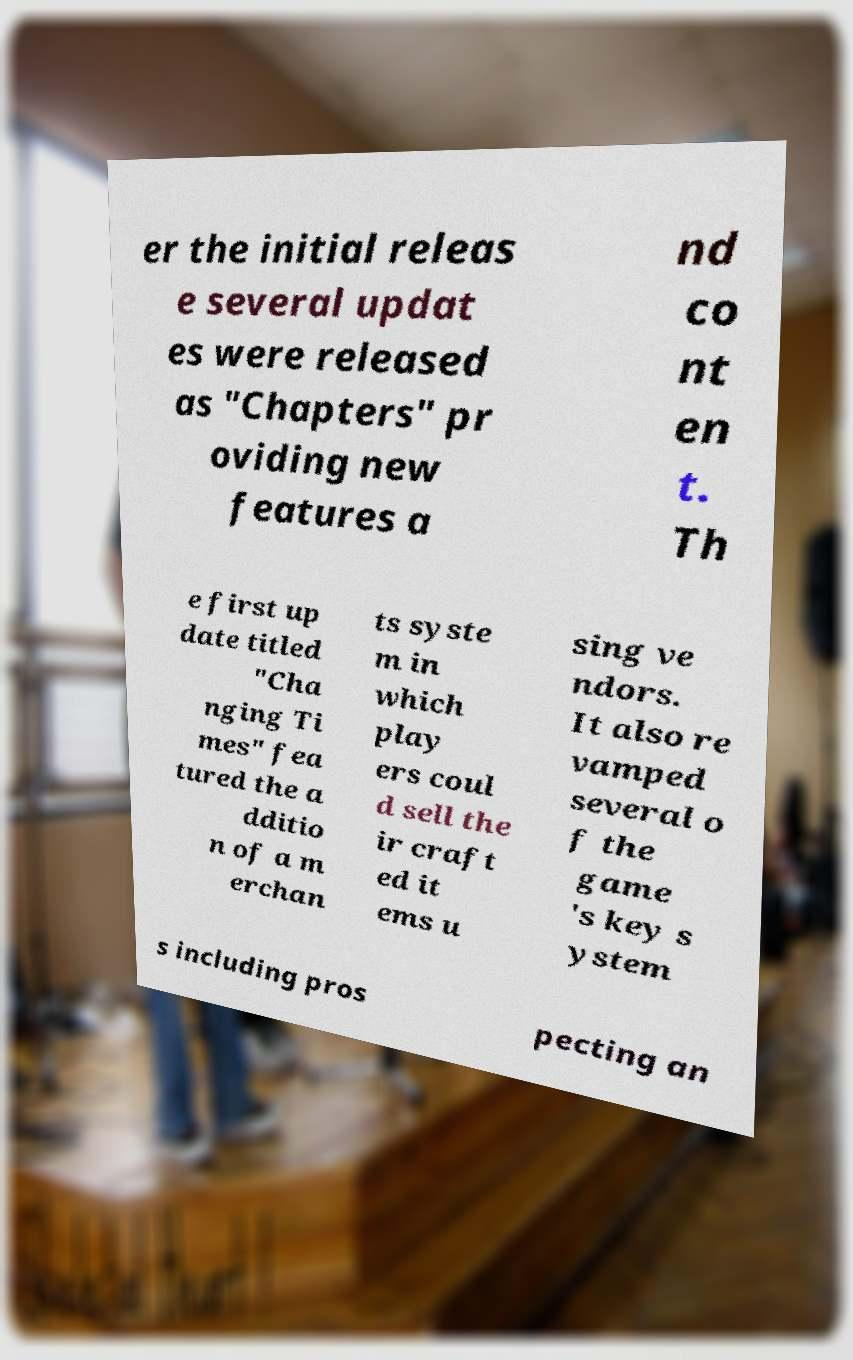Please read and relay the text visible in this image. What does it say? er the initial releas e several updat es were released as "Chapters" pr oviding new features a nd co nt en t. Th e first up date titled "Cha nging Ti mes" fea tured the a dditio n of a m erchan ts syste m in which play ers coul d sell the ir craft ed it ems u sing ve ndors. It also re vamped several o f the game 's key s ystem s including pros pecting an 